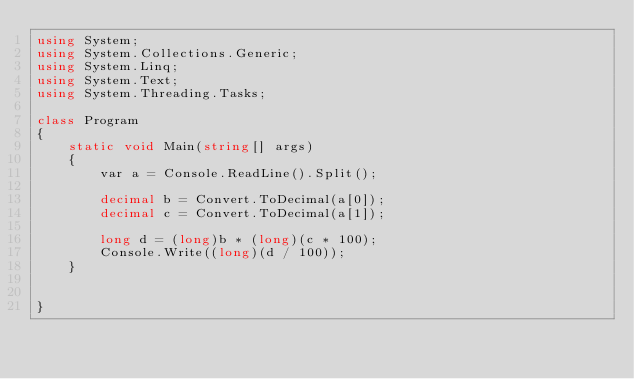<code> <loc_0><loc_0><loc_500><loc_500><_C#_>using System;
using System.Collections.Generic;
using System.Linq;
using System.Text;
using System.Threading.Tasks;

class Program
{
    static void Main(string[] args)
    {
        var a = Console.ReadLine().Split();

        decimal b = Convert.ToDecimal(a[0]);
        decimal c = Convert.ToDecimal(a[1]);

        long d = (long)b * (long)(c * 100);
        Console.Write((long)(d / 100));
    }

  
}</code> 